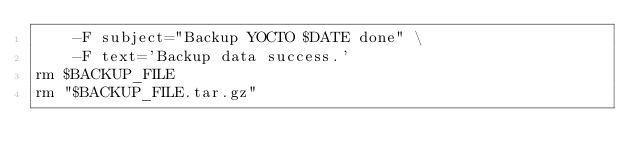<code> <loc_0><loc_0><loc_500><loc_500><_Bash_>    -F subject="Backup YOCTO $DATE done" \
    -F text='Backup data success.'
rm $BACKUP_FILE
rm "$BACKUP_FILE.tar.gz"
</code> 